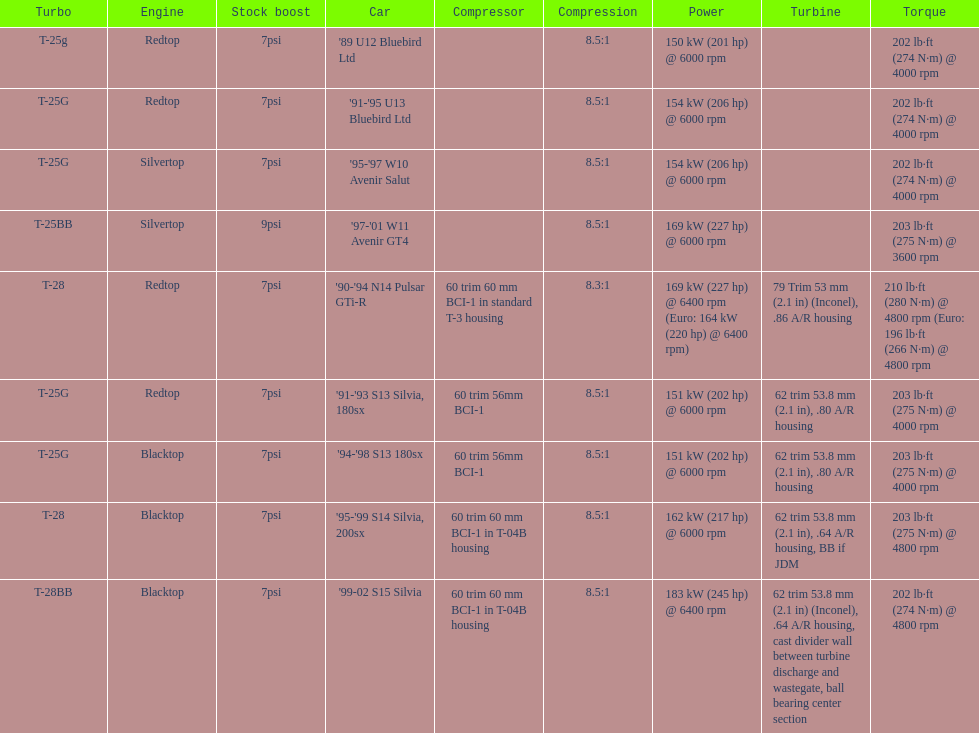What is his/her compression for the 90-94 n14 pulsar gti-r? 8.3:1. 